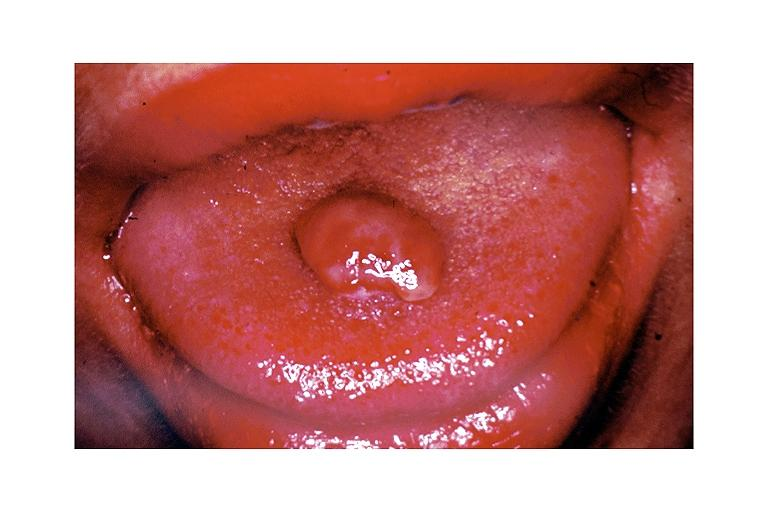s metastatic neuroblastoma present?
Answer the question using a single word or phrase. No 